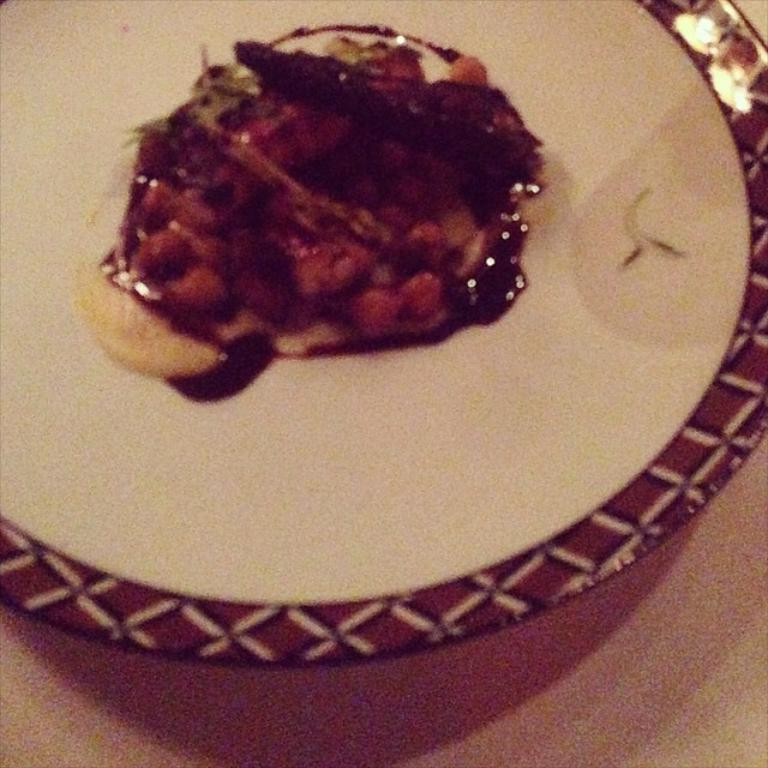What is present on the plate in the image? There is food on the plate in the image. What can be found beneath the plate? There is a surface at the bottom of the image. Reasoning: Let's think step by following the guidelines to produce the conversation. We start by identifying the main subject in the image, which is the plate. Then, we describe what is on the plate, which is food. Finally, we mention the surface beneath the plate. Each question is designed to elicit a specific detail about the image that is known from the provided facts. Absurd Question/Answer: What type of sail is visible on the plate in the image? There is no sail present in the image; it is a plate with food on it. What invention is being demonstrated in the image? There is no invention being demonstrated in the image; it is a plate with food on it. What type of organization is represented by the plate in the image? There is no organization represented by the plate in the image; it is a plate with food on it. 